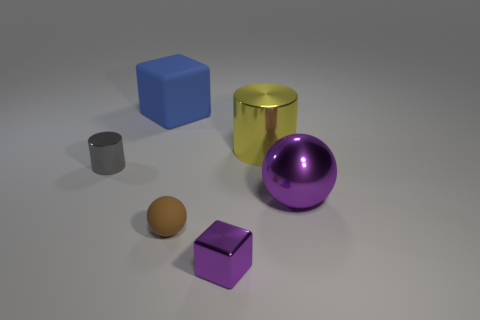Subtract 2 balls. How many balls are left? 0 Add 3 yellow metal cylinders. How many objects exist? 9 Subtract all cylinders. How many objects are left? 4 Subtract all blue cubes. Subtract all yellow cylinders. How many cubes are left? 1 Subtract all green spheres. How many cyan cubes are left? 0 Subtract all big spheres. Subtract all tiny blue matte cubes. How many objects are left? 5 Add 6 purple cubes. How many purple cubes are left? 7 Add 2 small cyan shiny things. How many small cyan shiny things exist? 2 Subtract 0 brown cylinders. How many objects are left? 6 